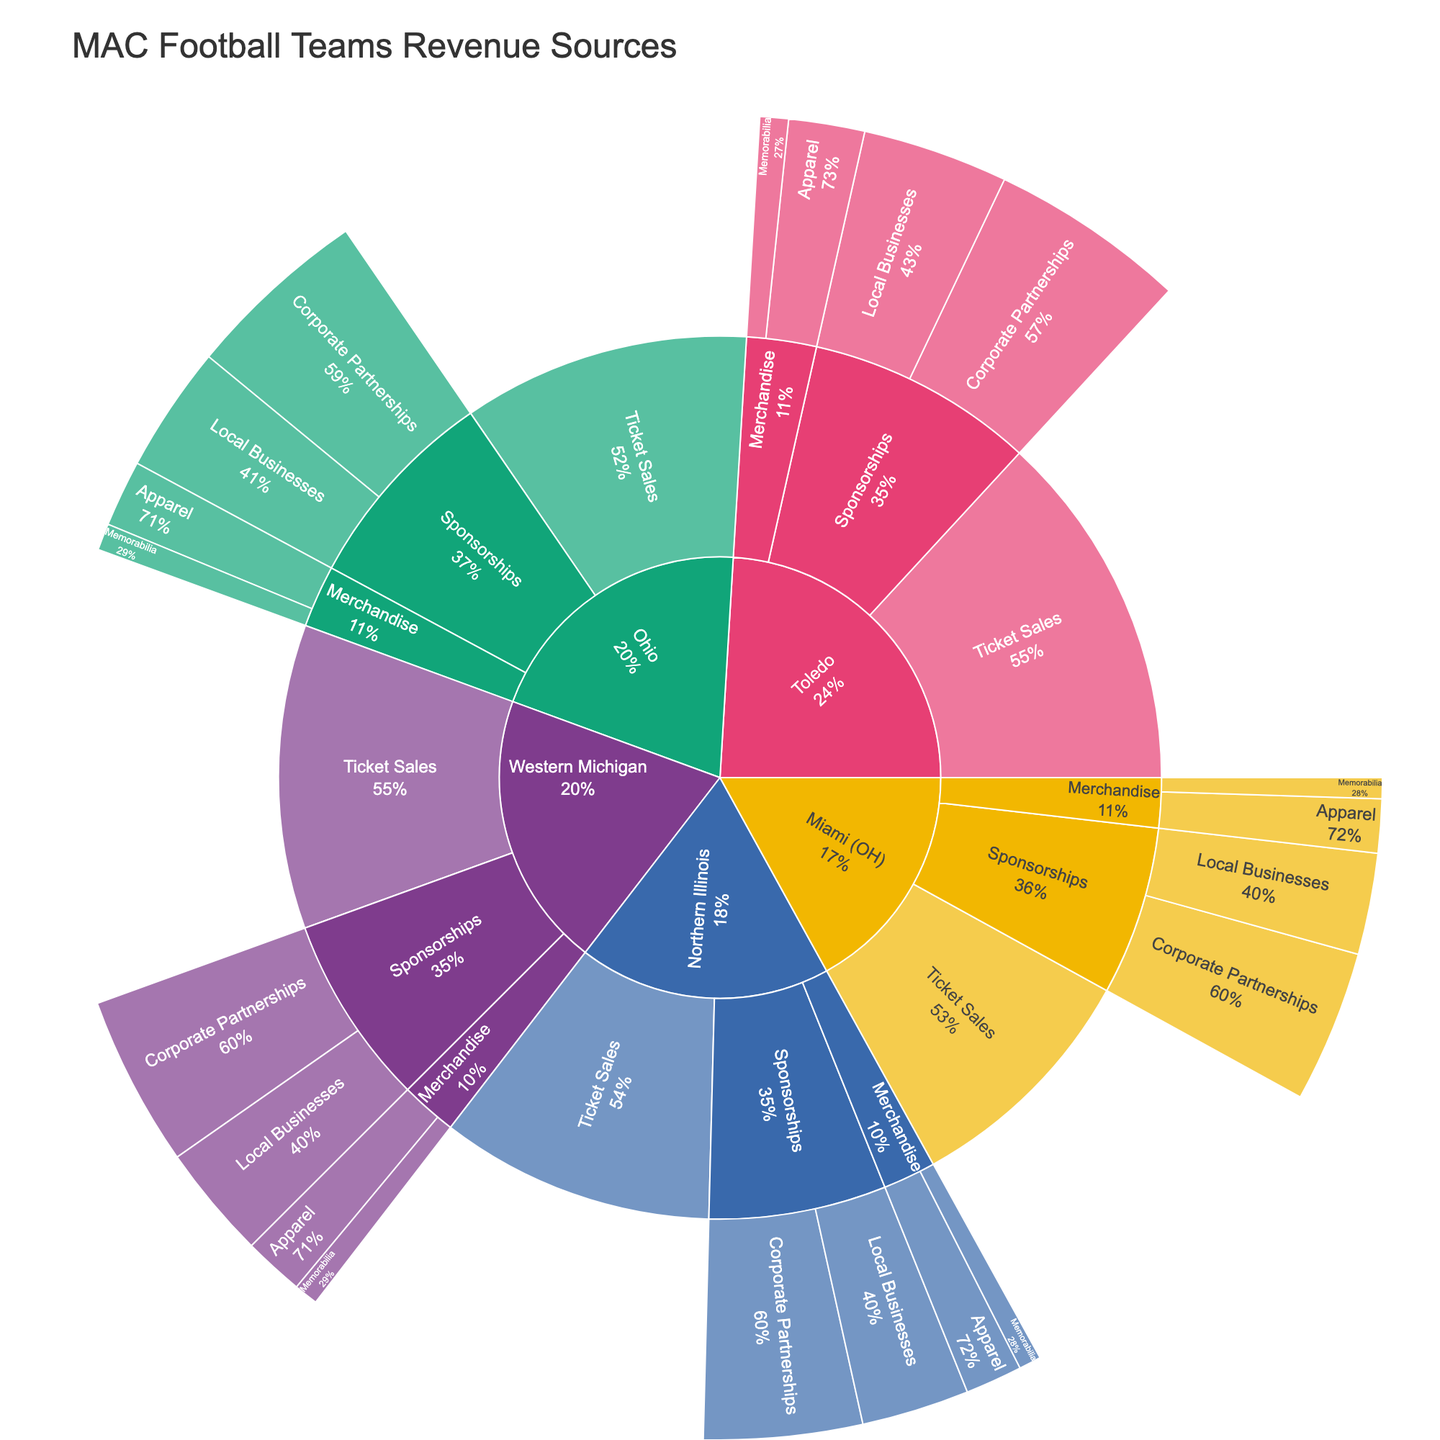Which team has the highest revenue from ticket sales? Look at the sections for each team under the "Ticket Sales" category. Toledo has the highest revenue from ticket sales at $8,500,000.
Answer: Toledo What is the total revenue from merchandise for Northern Illinois? Sum the values of "Apparel" and "Memorabilia" subcategories under "Merchandise" for Northern Illinois: $900,000 + $350,000 = $1,250,000.
Answer: $1,250,000 Which team generates more revenue from Local Businesses in sponsorships, Miami (OH) or Western Michigan? Compare the "Local Businesses" subcategory under "Sponsorships" for both teams. Miami (OH) has $1,600,000, while Western Michigan has $1,800,000.
Answer: Western Michigan Which category contributes the most to Ohio's total revenue? Compare the "Ticket Sales," "Merchandise," and "Sponsorships" categories for Ohio. "Ticket Sales" contributes the most with $6,800,000.
Answer: Ticket Sales How does the combined revenue from Corporate Partnerships compare between Toledo and Ohio? Sum the values of the "Corporate Partnerships" subcategory in Sponsorships for both teams. Toledo has $3,100,000 and Ohio has $2,900,000. The difference is $3,100,000 - $2,900,000 = $200,000.
Answer: Toledo has $200,000 more In the Merchandise category, which team has higher revenue from Apparel, Western Michigan or Ohio? Compare the Apparel subcategory under Merchandise for both teams. Western Michigan has $950,000, while Ohio has $1,050,000.
Answer: Ohio What is the total revenue generated by all teams combined from memorabilia sales? Sum the values of the Memorabilia subcategories across all teams: $450,000 (Toledo) + $380,000 (Western Michigan) + $420,000 (Ohio) + $350,000 (Northern Illinois) + $330,000 (Miami (OH)) = $1,930,000.
Answer: $1,930,000 Which team has the lowest overall revenue from Sponsorships? Sum the values of "Local Businesses" and "Corporate Partnerships" for each team, and find the smallest total. Miami (OH) has the lowest overall revenue from Sponsorships at $4,000,000.
Answer: Miami (OH) How much more does Toledo earn from Corporate Partnerships than Miami (OH)? Subtract the value of Corporate Partnerships subcategory under Sponsorships for Miami (OH) from Toledo: $3,100,000 - $2,400,000 = $700,000.
Answer: $700,000 What percent of Northern Illinois's total revenue comes from Ticket Sales? First, calculate Northern Illinois's total revenue: $6,500,000 (Ticket Sales) + $900,000 (Apparel) + $350,000 (Memorabilia) + $1,700,000 (Local Businesses) + $2,500,000 (Corporate Partnerships) = $11,950,000. Then, find the percentage: ($6,500,000 / $11,950,000) * 100 ≈ 54.39%.
Answer: ≈54.39% 